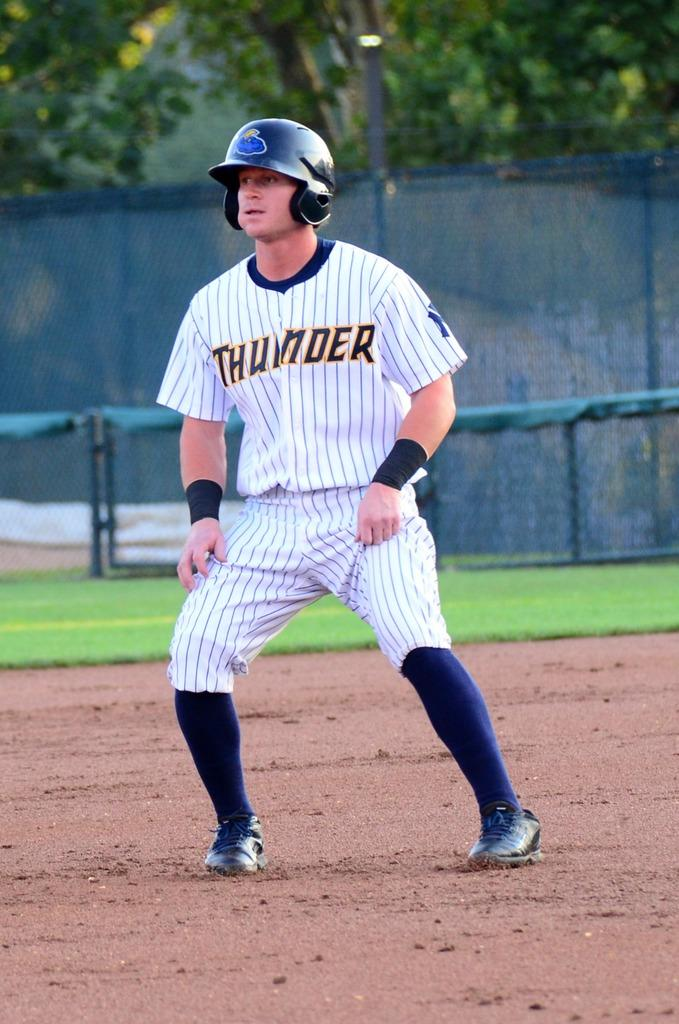Provide a one-sentence caption for the provided image. Baseball player with a thunder jersey and helmet on field. 